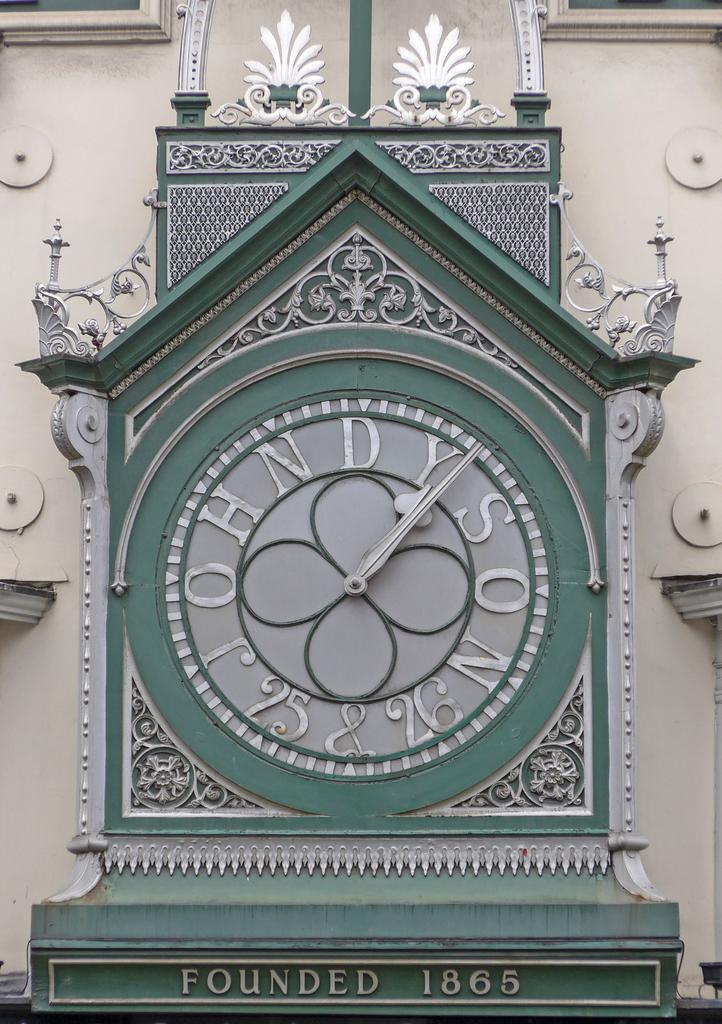<image>
Summarize the visual content of the image. A clock says founded in 1865 under it 